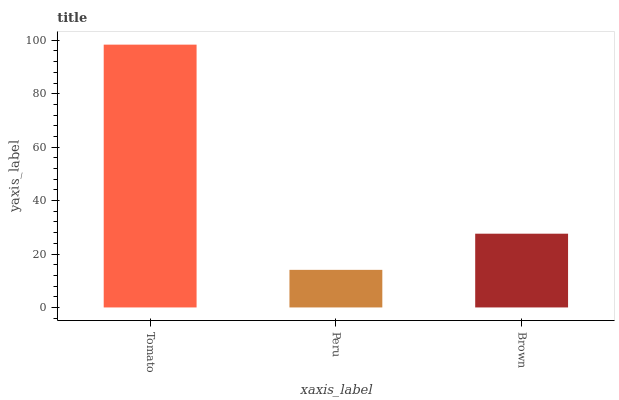Is Brown the minimum?
Answer yes or no. No. Is Brown the maximum?
Answer yes or no. No. Is Brown greater than Peru?
Answer yes or no. Yes. Is Peru less than Brown?
Answer yes or no. Yes. Is Peru greater than Brown?
Answer yes or no. No. Is Brown less than Peru?
Answer yes or no. No. Is Brown the high median?
Answer yes or no. Yes. Is Brown the low median?
Answer yes or no. Yes. Is Peru the high median?
Answer yes or no. No. Is Tomato the low median?
Answer yes or no. No. 